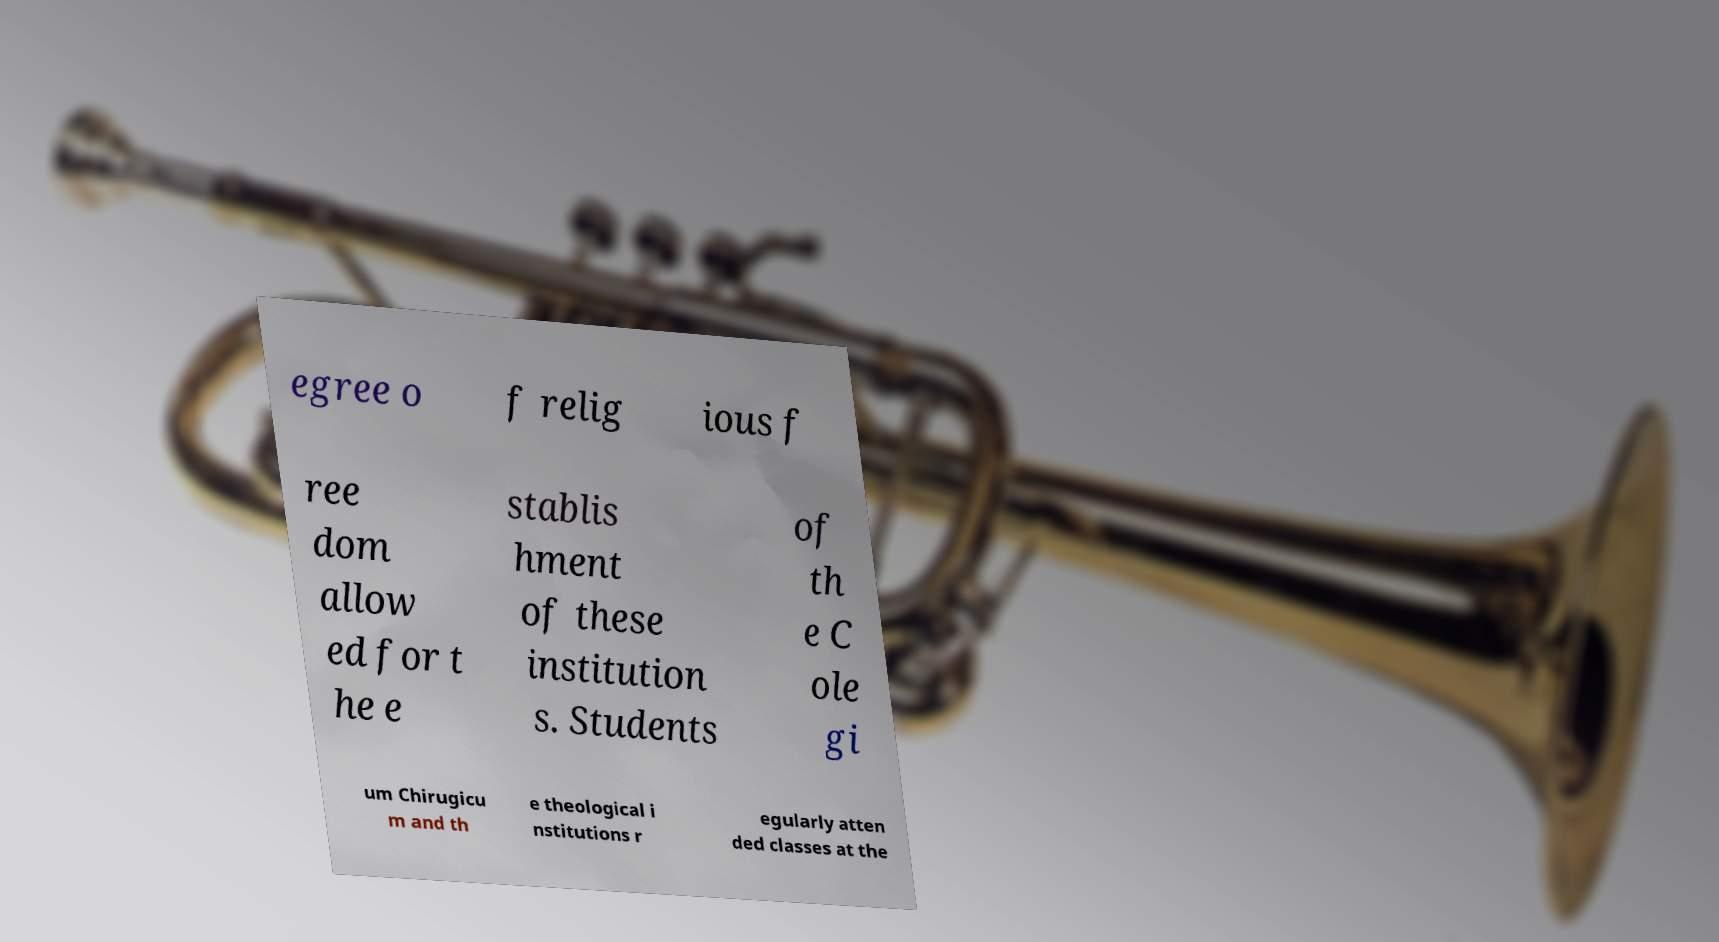Can you read and provide the text displayed in the image?This photo seems to have some interesting text. Can you extract and type it out for me? egree o f relig ious f ree dom allow ed for t he e stablis hment of these institution s. Students of th e C ole gi um Chirugicu m and th e theological i nstitutions r egularly atten ded classes at the 